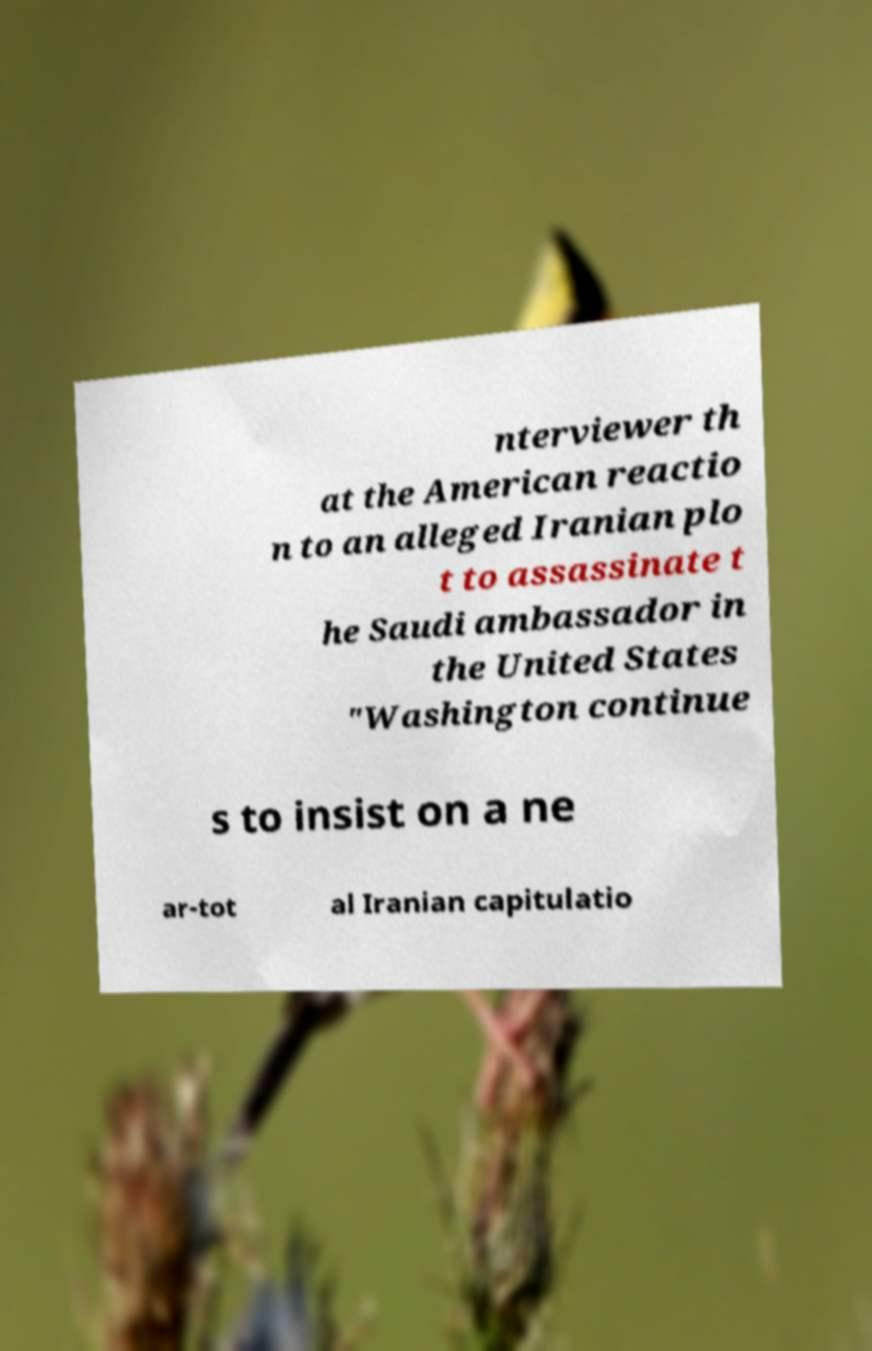Could you extract and type out the text from this image? nterviewer th at the American reactio n to an alleged Iranian plo t to assassinate t he Saudi ambassador in the United States "Washington continue s to insist on a ne ar-tot al Iranian capitulatio 